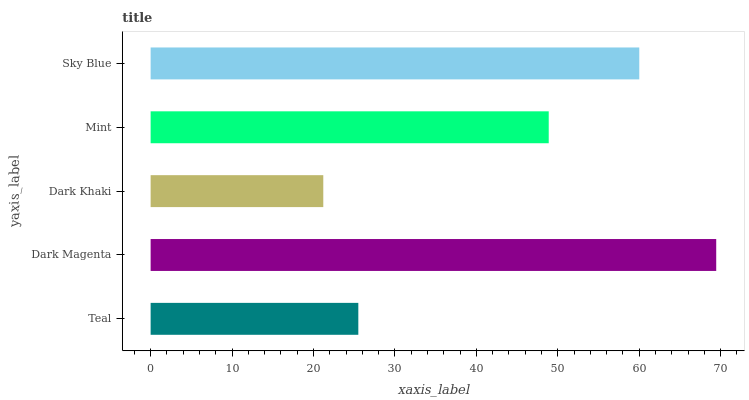Is Dark Khaki the minimum?
Answer yes or no. Yes. Is Dark Magenta the maximum?
Answer yes or no. Yes. Is Dark Magenta the minimum?
Answer yes or no. No. Is Dark Khaki the maximum?
Answer yes or no. No. Is Dark Magenta greater than Dark Khaki?
Answer yes or no. Yes. Is Dark Khaki less than Dark Magenta?
Answer yes or no. Yes. Is Dark Khaki greater than Dark Magenta?
Answer yes or no. No. Is Dark Magenta less than Dark Khaki?
Answer yes or no. No. Is Mint the high median?
Answer yes or no. Yes. Is Mint the low median?
Answer yes or no. Yes. Is Teal the high median?
Answer yes or no. No. Is Dark Magenta the low median?
Answer yes or no. No. 